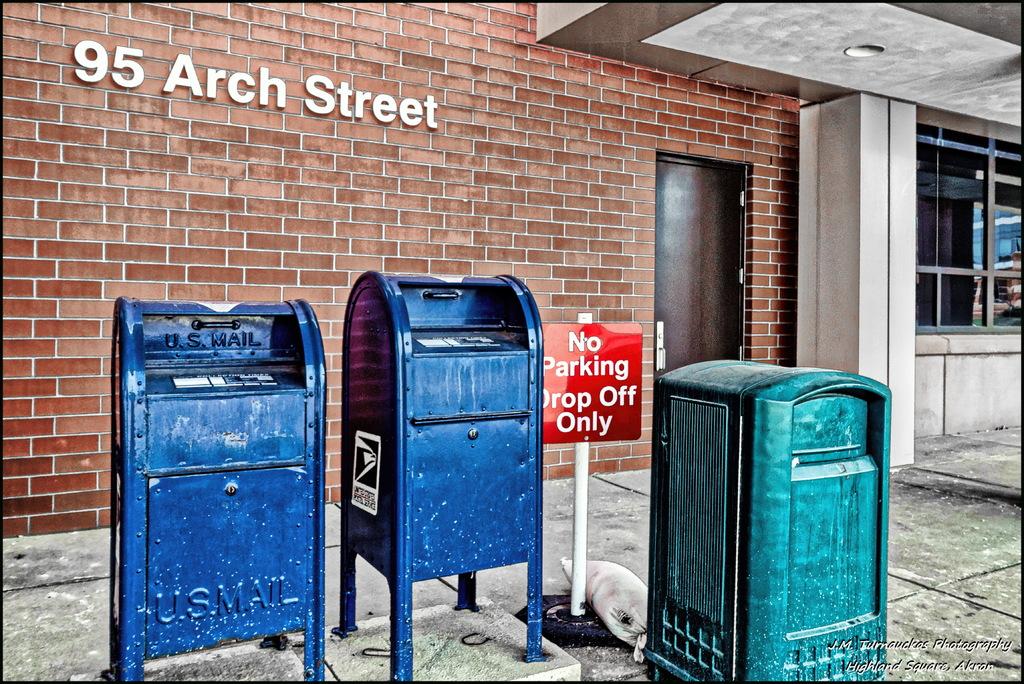What can you only do?
Provide a succinct answer. Drop off. What is the address on the building?
Your answer should be compact. 95 arch street. 